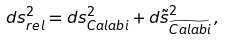<formula> <loc_0><loc_0><loc_500><loc_500>d s _ { r e l } ^ { 2 } = d s _ { C a l a b i } ^ { 2 } + d \tilde { s } ^ { 2 } _ { \widetilde { C a l a b i } } \, ,</formula> 